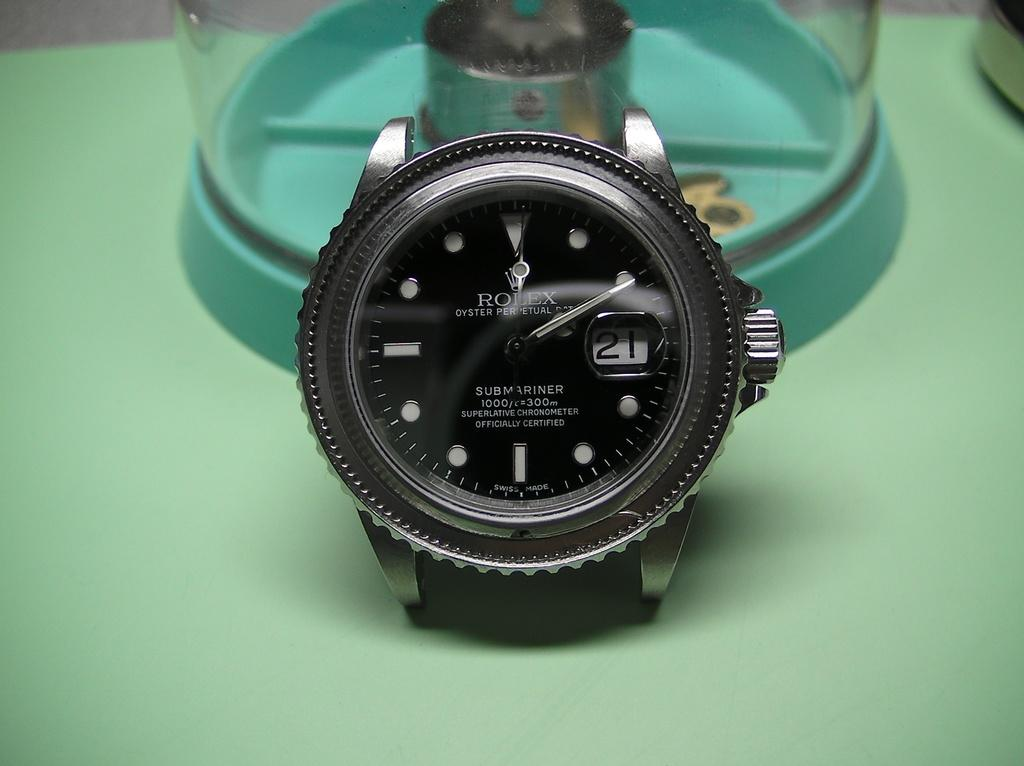<image>
Present a compact description of the photo's key features. Rolex Submariner is displayed on this expensive looking watch. 